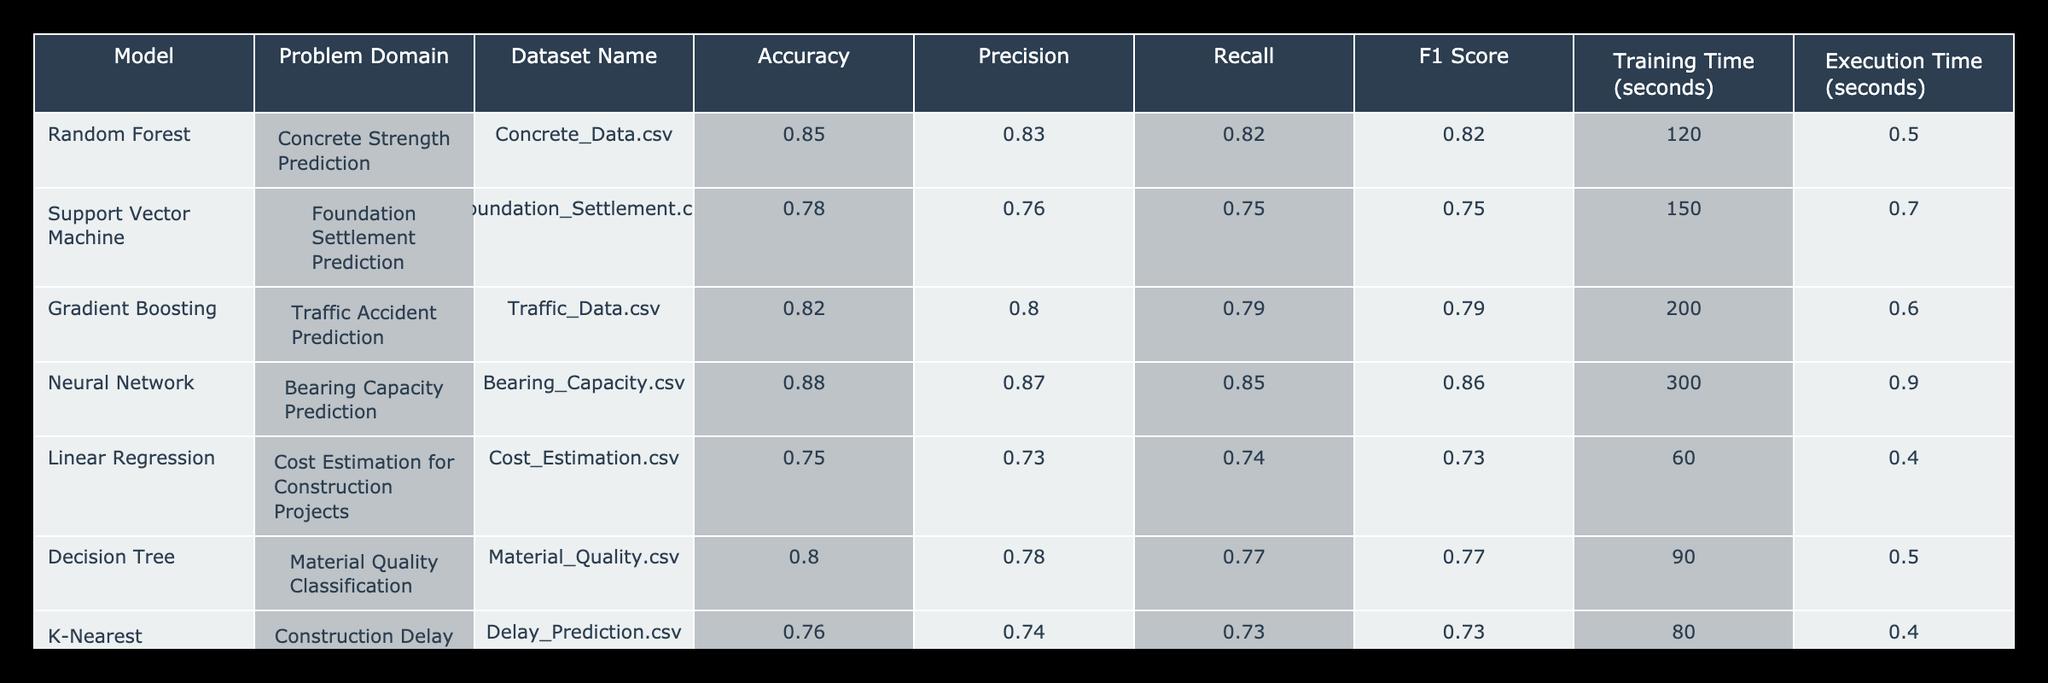What model achieved the highest accuracy? By looking through the 'Accuracy' column, we can identify which model has the highest value. The Neural Network model has an accuracy of 0.88, which is higher than all other models listed.
Answer: Neural Network Which model has the lowest F1 Score? The 'F1 Score' column allows us to see the values for each model. The Linear Regression model has the lowest F1 Score of 0.73 compared to the others.
Answer: Linear Regression What is the average training time for all models? To find the average training time, we sum the 'Training Time' values: 120 + 150 + 200 + 300 + 60 + 90 + 80 = 1,000 seconds. Then, divide by the number of models, which is 7. Thus, the average training time is 1,000 / 7 ≈ 142.86 seconds.
Answer: 142.86 seconds Is the Precision of the Random Forest model greater than that of the Support Vector Machine model? By comparing the 'Precision' values in the respective rows for both models, we see Random Forest has a Precision of 0.83 and Support Vector Machine has 0.76. Since 0.83 is greater than 0.76, the statement is true.
Answer: Yes If we consider models with accuracy greater than 0.80, what is the number of models with a Recall greater than 0.80? First, we note the models with accuracy above 0.80: Random Forest (0.85), Gradient Boosting (0.82), and Neural Network (0.88). Next, we check their Recall: Random Forest (0.82), Gradient Boosting (0.79), Neural Network (0.85). Only Random Forest and Neural Network have Recall values above 0.80. So, the count is 2.
Answer: 2 